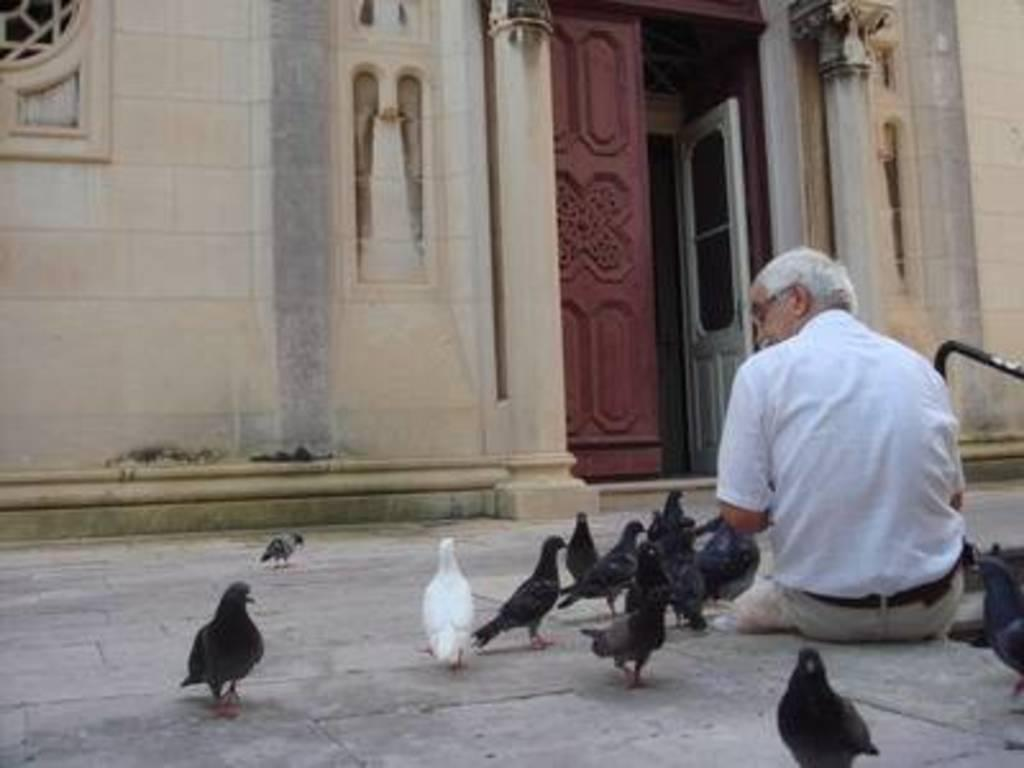What is the man in the image doing? The man is sitting on the ground in the image. What is present around the man? There are many birds around the man. What can be seen in the background of the image? There is architecture visible in the background of the image. What is the state of the door in the architecture? The door of the architecture is open. What type of honey is being collected by the man in the image? There is no honey or honey collection activity present in the image. 